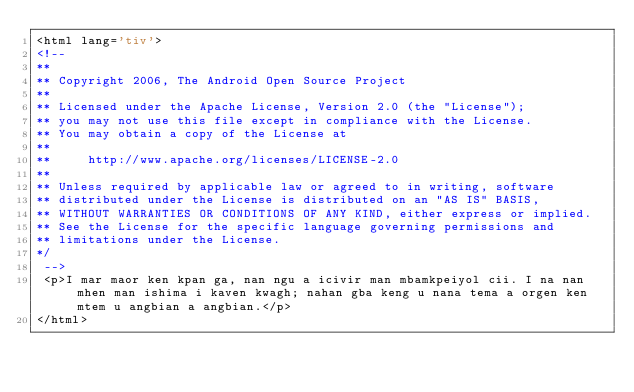<code> <loc_0><loc_0><loc_500><loc_500><_HTML_><html lang='tiv'>
<!-- 
**
** Copyright 2006, The Android Open Source Project
**
** Licensed under the Apache License, Version 2.0 (the "License");
** you may not use this file except in compliance with the License.
** You may obtain a copy of the License at
**
**     http://www.apache.org/licenses/LICENSE-2.0
**
** Unless required by applicable law or agreed to in writing, software
** distributed under the License is distributed on an "AS IS" BASIS,
** WITHOUT WARRANTIES OR CONDITIONS OF ANY KIND, either express or implied.
** See the License for the specific language governing permissions and
** limitations under the License.
*/
 -->
 <p>I mar maor ken kpan ga, nan ngu a icivir man mbamkpeiyol cii. I na nan mhen man ishima i kaven kwagh; nahan gba keng u nana tema a orgen ken mtem u angbian a angbian.</p>
</html>
</code> 